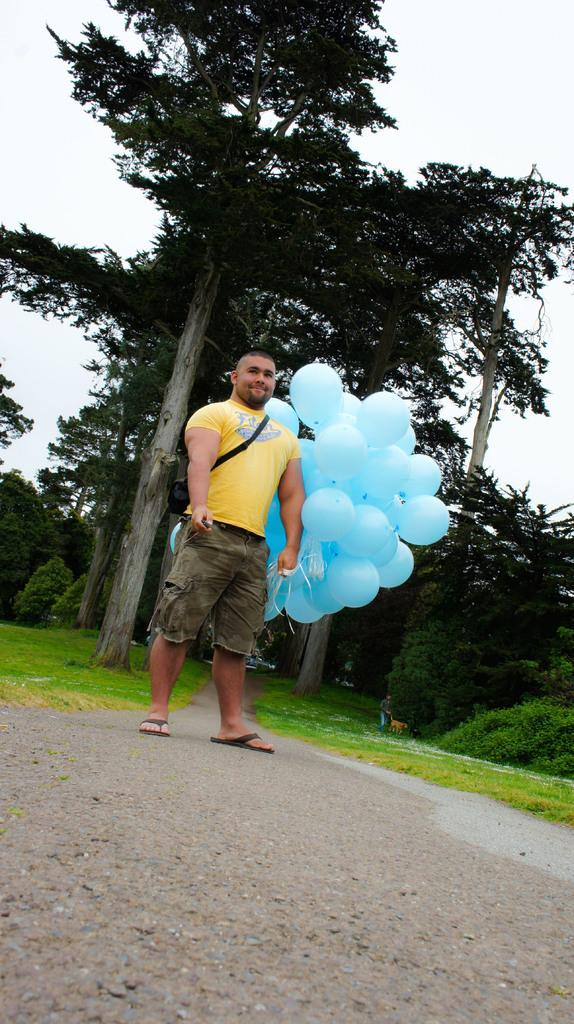What is the person in the image doing? The person is standing on the ground and holding balloons in one hand. What can be seen in the background of the image? There is grass, bushes, creepers, trees, and the sky visible in the background of the image. What type of faucet can be seen in the image? There is no faucet present in the image. What hobbies does the person holding balloons have? The image does not provide information about the person's hobbies. 